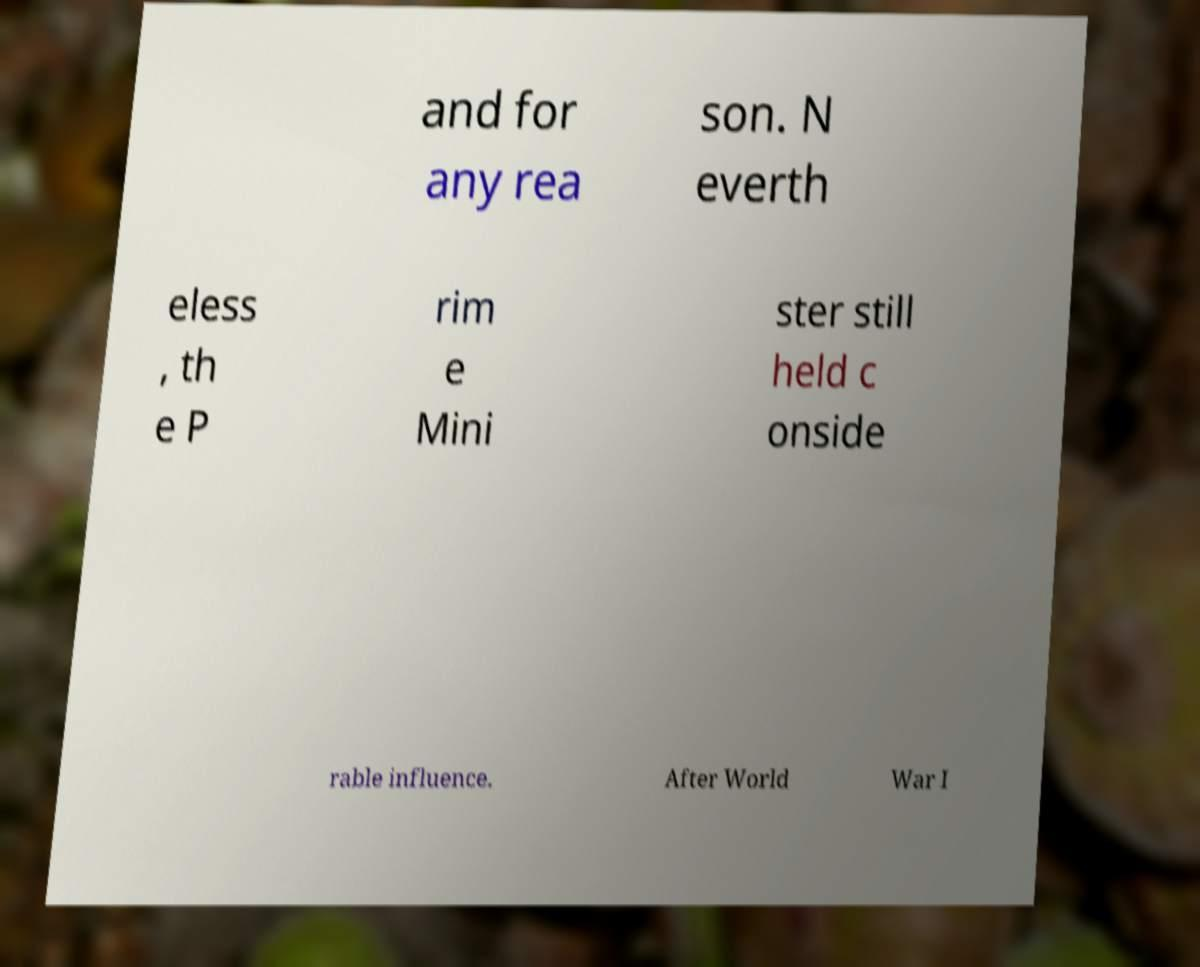Please read and relay the text visible in this image. What does it say? and for any rea son. N everth eless , th e P rim e Mini ster still held c onside rable influence. After World War I 